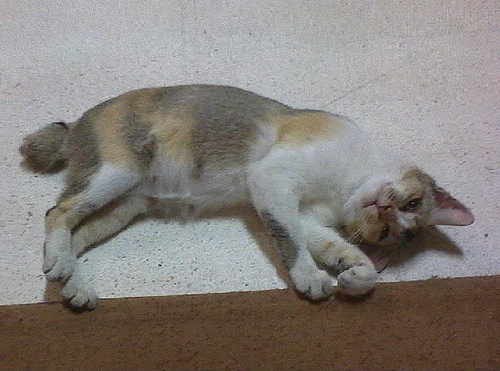<image>
Can you confirm if the cat is on the rug? Yes. Looking at the image, I can see the cat is positioned on top of the rug, with the rug providing support. 